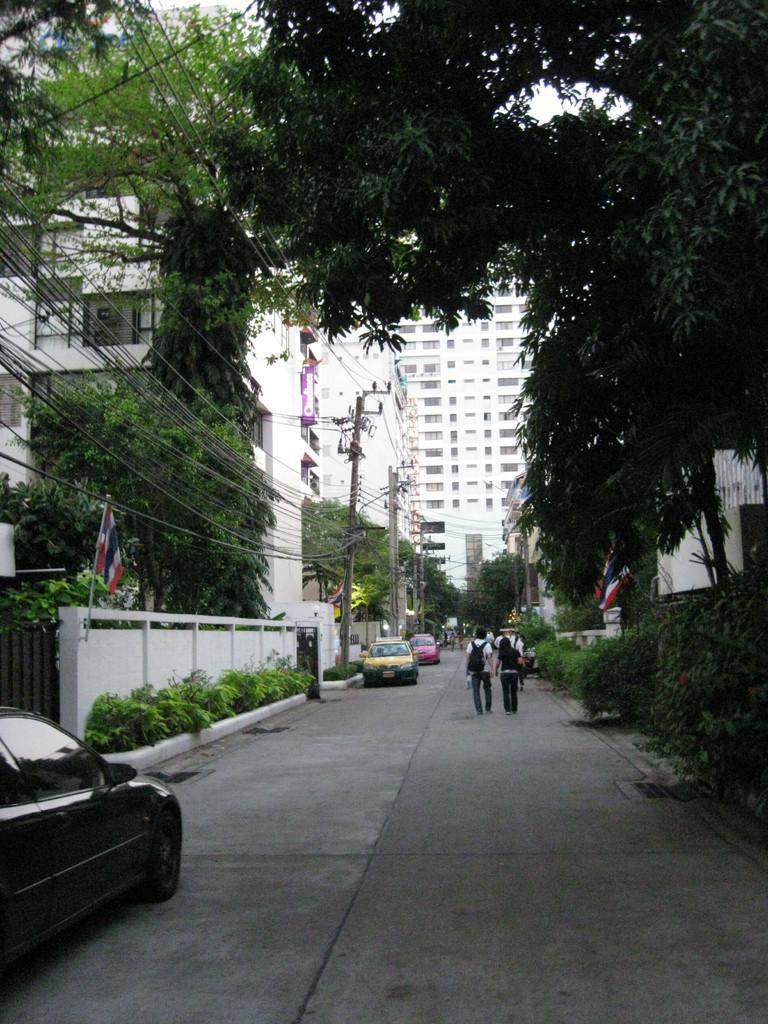Please provide a concise description of this image. In this image we can see few people carrying bags and walking on the road, there are some vehicles on the road and we can see some buildings, electrical poles with wires, trees, plants and flags. 